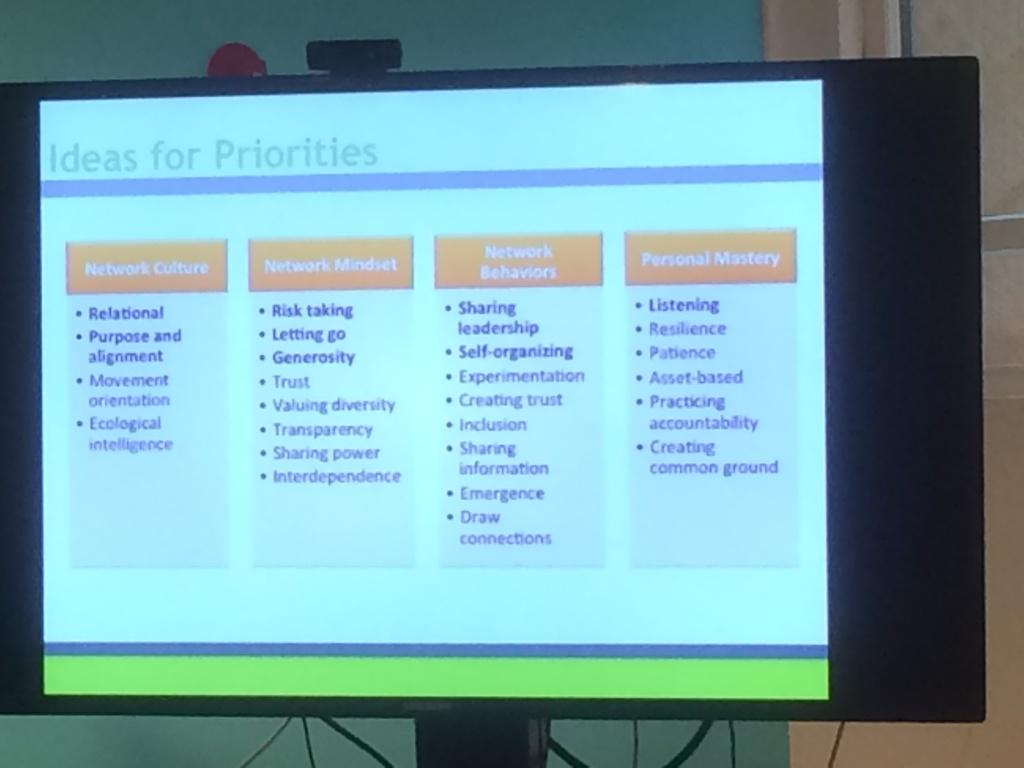<image>
Provide a brief description of the given image. Computer monitor which shows the Ideas for Priorities. 